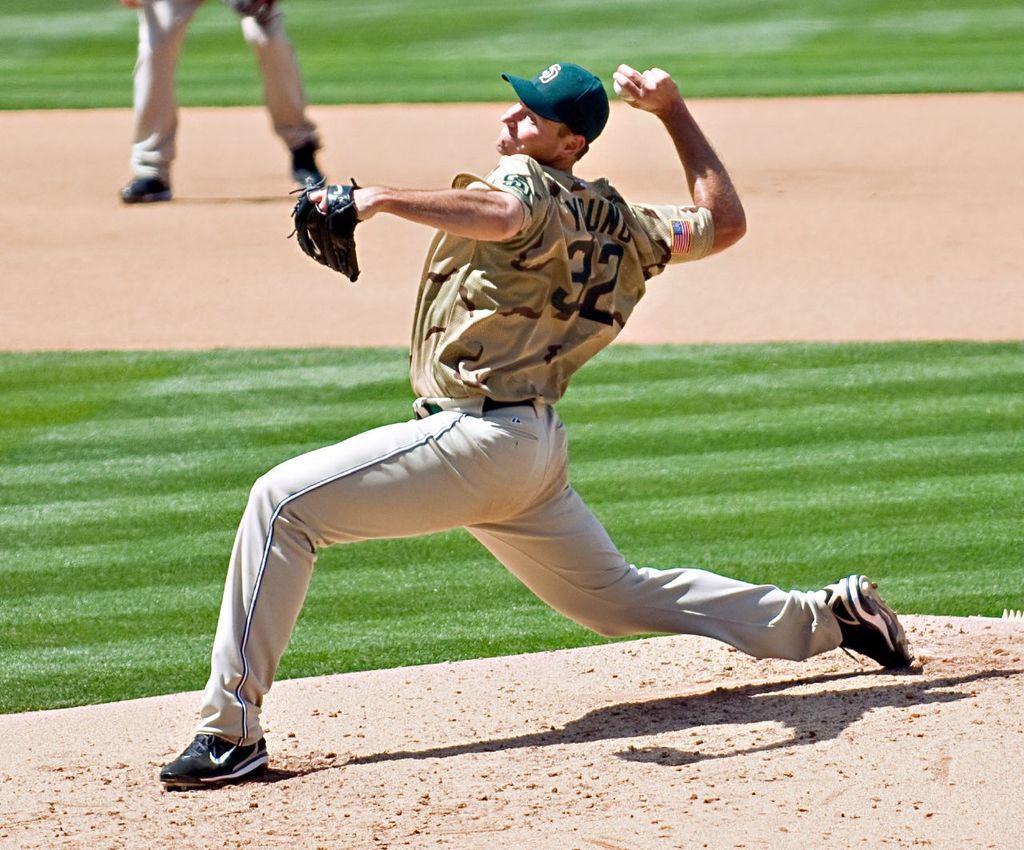Describe this image in one or two sentences. In this picture there is a man and he might be standing and he is holding the ball. At the back there is a person standing. At the bottom there is grass and there is ground. 